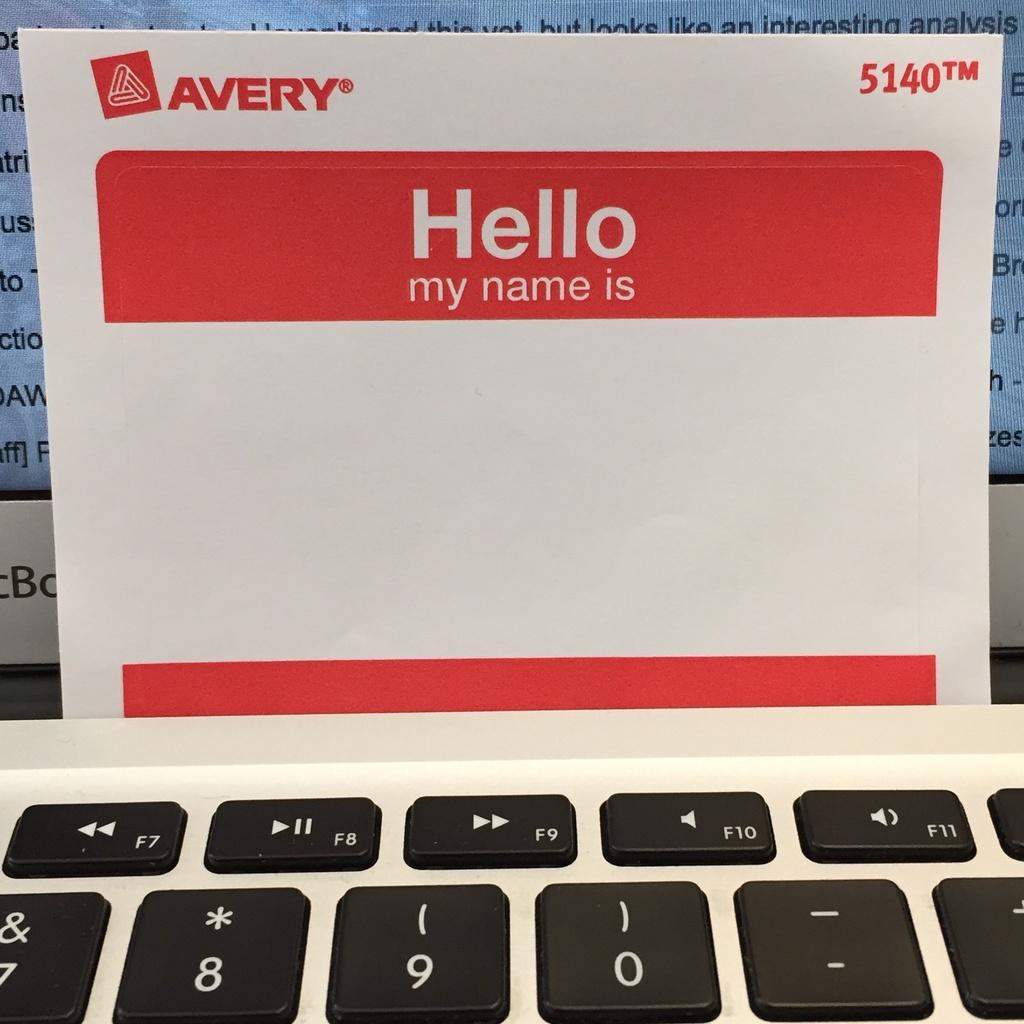<image>
Offer a succinct explanation of the picture presented. A blank Avery brand personal name tag with red borders on a keyboard. 